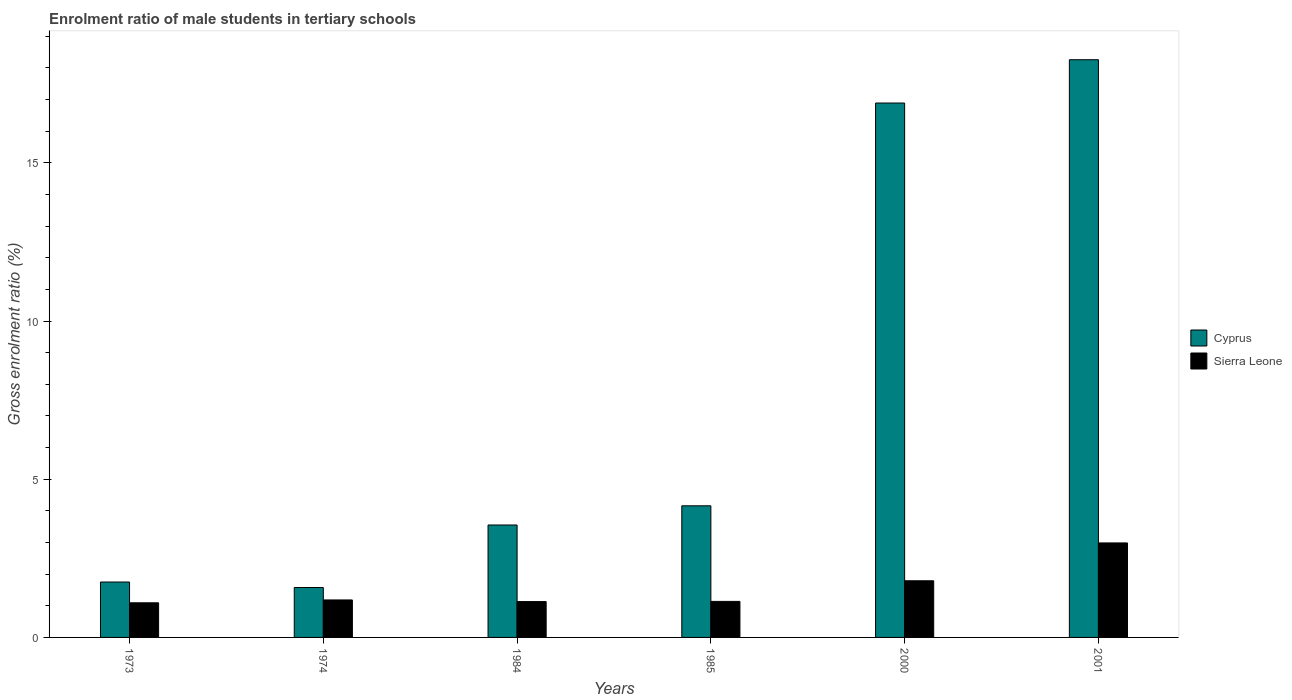How many different coloured bars are there?
Make the answer very short. 2. Are the number of bars per tick equal to the number of legend labels?
Your response must be concise. Yes. Are the number of bars on each tick of the X-axis equal?
Offer a very short reply. Yes. How many bars are there on the 6th tick from the left?
Offer a very short reply. 2. How many bars are there on the 6th tick from the right?
Your response must be concise. 2. What is the label of the 2nd group of bars from the left?
Provide a short and direct response. 1974. In how many cases, is the number of bars for a given year not equal to the number of legend labels?
Your response must be concise. 0. What is the enrolment ratio of male students in tertiary schools in Sierra Leone in 1984?
Your answer should be very brief. 1.13. Across all years, what is the maximum enrolment ratio of male students in tertiary schools in Cyprus?
Your answer should be compact. 18.26. Across all years, what is the minimum enrolment ratio of male students in tertiary schools in Sierra Leone?
Provide a short and direct response. 1.09. In which year was the enrolment ratio of male students in tertiary schools in Sierra Leone minimum?
Offer a very short reply. 1973. What is the total enrolment ratio of male students in tertiary schools in Sierra Leone in the graph?
Make the answer very short. 9.33. What is the difference between the enrolment ratio of male students in tertiary schools in Cyprus in 1973 and that in 1984?
Give a very brief answer. -1.8. What is the difference between the enrolment ratio of male students in tertiary schools in Sierra Leone in 2000 and the enrolment ratio of male students in tertiary schools in Cyprus in 1973?
Your answer should be compact. 0.04. What is the average enrolment ratio of male students in tertiary schools in Sierra Leone per year?
Offer a terse response. 1.55. In the year 2001, what is the difference between the enrolment ratio of male students in tertiary schools in Sierra Leone and enrolment ratio of male students in tertiary schools in Cyprus?
Make the answer very short. -15.27. In how many years, is the enrolment ratio of male students in tertiary schools in Sierra Leone greater than 15 %?
Your response must be concise. 0. What is the ratio of the enrolment ratio of male students in tertiary schools in Sierra Leone in 1973 to that in 1984?
Offer a very short reply. 0.97. Is the enrolment ratio of male students in tertiary schools in Cyprus in 1973 less than that in 1984?
Give a very brief answer. Yes. What is the difference between the highest and the second highest enrolment ratio of male students in tertiary schools in Sierra Leone?
Your answer should be compact. 1.2. What is the difference between the highest and the lowest enrolment ratio of male students in tertiary schools in Sierra Leone?
Offer a very short reply. 1.89. What does the 2nd bar from the left in 1985 represents?
Offer a terse response. Sierra Leone. What does the 2nd bar from the right in 1985 represents?
Your answer should be very brief. Cyprus. How many bars are there?
Offer a terse response. 12. Are all the bars in the graph horizontal?
Your answer should be very brief. No. How many years are there in the graph?
Provide a succinct answer. 6. Are the values on the major ticks of Y-axis written in scientific E-notation?
Give a very brief answer. No. How many legend labels are there?
Provide a succinct answer. 2. What is the title of the graph?
Provide a short and direct response. Enrolment ratio of male students in tertiary schools. What is the label or title of the X-axis?
Offer a terse response. Years. What is the Gross enrolment ratio (%) in Cyprus in 1973?
Your response must be concise. 1.75. What is the Gross enrolment ratio (%) of Sierra Leone in 1973?
Your answer should be very brief. 1.09. What is the Gross enrolment ratio (%) in Cyprus in 1974?
Provide a short and direct response. 1.58. What is the Gross enrolment ratio (%) in Sierra Leone in 1974?
Provide a succinct answer. 1.18. What is the Gross enrolment ratio (%) in Cyprus in 1984?
Make the answer very short. 3.55. What is the Gross enrolment ratio (%) in Sierra Leone in 1984?
Provide a short and direct response. 1.13. What is the Gross enrolment ratio (%) of Cyprus in 1985?
Provide a succinct answer. 4.16. What is the Gross enrolment ratio (%) in Sierra Leone in 1985?
Make the answer very short. 1.14. What is the Gross enrolment ratio (%) of Cyprus in 2000?
Offer a very short reply. 16.89. What is the Gross enrolment ratio (%) of Sierra Leone in 2000?
Keep it short and to the point. 1.79. What is the Gross enrolment ratio (%) of Cyprus in 2001?
Your answer should be very brief. 18.26. What is the Gross enrolment ratio (%) in Sierra Leone in 2001?
Your answer should be compact. 2.99. Across all years, what is the maximum Gross enrolment ratio (%) in Cyprus?
Your response must be concise. 18.26. Across all years, what is the maximum Gross enrolment ratio (%) in Sierra Leone?
Your response must be concise. 2.99. Across all years, what is the minimum Gross enrolment ratio (%) in Cyprus?
Keep it short and to the point. 1.58. Across all years, what is the minimum Gross enrolment ratio (%) of Sierra Leone?
Ensure brevity in your answer.  1.09. What is the total Gross enrolment ratio (%) in Cyprus in the graph?
Your response must be concise. 46.19. What is the total Gross enrolment ratio (%) in Sierra Leone in the graph?
Your response must be concise. 9.33. What is the difference between the Gross enrolment ratio (%) of Cyprus in 1973 and that in 1974?
Your response must be concise. 0.17. What is the difference between the Gross enrolment ratio (%) of Sierra Leone in 1973 and that in 1974?
Give a very brief answer. -0.09. What is the difference between the Gross enrolment ratio (%) in Cyprus in 1973 and that in 1984?
Offer a very short reply. -1.8. What is the difference between the Gross enrolment ratio (%) of Sierra Leone in 1973 and that in 1984?
Ensure brevity in your answer.  -0.04. What is the difference between the Gross enrolment ratio (%) of Cyprus in 1973 and that in 1985?
Provide a succinct answer. -2.41. What is the difference between the Gross enrolment ratio (%) of Sierra Leone in 1973 and that in 1985?
Offer a terse response. -0.04. What is the difference between the Gross enrolment ratio (%) in Cyprus in 1973 and that in 2000?
Offer a very short reply. -15.14. What is the difference between the Gross enrolment ratio (%) of Sierra Leone in 1973 and that in 2000?
Give a very brief answer. -0.7. What is the difference between the Gross enrolment ratio (%) of Cyprus in 1973 and that in 2001?
Provide a short and direct response. -16.51. What is the difference between the Gross enrolment ratio (%) of Sierra Leone in 1973 and that in 2001?
Offer a very short reply. -1.89. What is the difference between the Gross enrolment ratio (%) of Cyprus in 1974 and that in 1984?
Your answer should be very brief. -1.98. What is the difference between the Gross enrolment ratio (%) of Sierra Leone in 1974 and that in 1984?
Your answer should be compact. 0.05. What is the difference between the Gross enrolment ratio (%) of Cyprus in 1974 and that in 1985?
Give a very brief answer. -2.58. What is the difference between the Gross enrolment ratio (%) in Sierra Leone in 1974 and that in 1985?
Ensure brevity in your answer.  0.05. What is the difference between the Gross enrolment ratio (%) of Cyprus in 1974 and that in 2000?
Offer a terse response. -15.31. What is the difference between the Gross enrolment ratio (%) in Sierra Leone in 1974 and that in 2000?
Provide a short and direct response. -0.61. What is the difference between the Gross enrolment ratio (%) of Cyprus in 1974 and that in 2001?
Give a very brief answer. -16.68. What is the difference between the Gross enrolment ratio (%) in Sierra Leone in 1974 and that in 2001?
Make the answer very short. -1.8. What is the difference between the Gross enrolment ratio (%) in Cyprus in 1984 and that in 1985?
Make the answer very short. -0.61. What is the difference between the Gross enrolment ratio (%) of Sierra Leone in 1984 and that in 1985?
Provide a succinct answer. -0.01. What is the difference between the Gross enrolment ratio (%) in Cyprus in 1984 and that in 2000?
Your response must be concise. -13.34. What is the difference between the Gross enrolment ratio (%) in Sierra Leone in 1984 and that in 2000?
Your answer should be very brief. -0.66. What is the difference between the Gross enrolment ratio (%) in Cyprus in 1984 and that in 2001?
Give a very brief answer. -14.71. What is the difference between the Gross enrolment ratio (%) in Sierra Leone in 1984 and that in 2001?
Your answer should be very brief. -1.85. What is the difference between the Gross enrolment ratio (%) of Cyprus in 1985 and that in 2000?
Keep it short and to the point. -12.73. What is the difference between the Gross enrolment ratio (%) of Sierra Leone in 1985 and that in 2000?
Provide a short and direct response. -0.65. What is the difference between the Gross enrolment ratio (%) of Cyprus in 1985 and that in 2001?
Ensure brevity in your answer.  -14.1. What is the difference between the Gross enrolment ratio (%) of Sierra Leone in 1985 and that in 2001?
Provide a short and direct response. -1.85. What is the difference between the Gross enrolment ratio (%) in Cyprus in 2000 and that in 2001?
Provide a short and direct response. -1.37. What is the difference between the Gross enrolment ratio (%) in Sierra Leone in 2000 and that in 2001?
Provide a short and direct response. -1.2. What is the difference between the Gross enrolment ratio (%) of Cyprus in 1973 and the Gross enrolment ratio (%) of Sierra Leone in 1974?
Offer a very short reply. 0.57. What is the difference between the Gross enrolment ratio (%) of Cyprus in 1973 and the Gross enrolment ratio (%) of Sierra Leone in 1984?
Offer a terse response. 0.62. What is the difference between the Gross enrolment ratio (%) of Cyprus in 1973 and the Gross enrolment ratio (%) of Sierra Leone in 1985?
Your response must be concise. 0.61. What is the difference between the Gross enrolment ratio (%) of Cyprus in 1973 and the Gross enrolment ratio (%) of Sierra Leone in 2000?
Provide a succinct answer. -0.04. What is the difference between the Gross enrolment ratio (%) of Cyprus in 1973 and the Gross enrolment ratio (%) of Sierra Leone in 2001?
Your response must be concise. -1.24. What is the difference between the Gross enrolment ratio (%) in Cyprus in 1974 and the Gross enrolment ratio (%) in Sierra Leone in 1984?
Ensure brevity in your answer.  0.44. What is the difference between the Gross enrolment ratio (%) in Cyprus in 1974 and the Gross enrolment ratio (%) in Sierra Leone in 1985?
Ensure brevity in your answer.  0.44. What is the difference between the Gross enrolment ratio (%) in Cyprus in 1974 and the Gross enrolment ratio (%) in Sierra Leone in 2000?
Give a very brief answer. -0.21. What is the difference between the Gross enrolment ratio (%) in Cyprus in 1974 and the Gross enrolment ratio (%) in Sierra Leone in 2001?
Offer a very short reply. -1.41. What is the difference between the Gross enrolment ratio (%) of Cyprus in 1984 and the Gross enrolment ratio (%) of Sierra Leone in 1985?
Your response must be concise. 2.42. What is the difference between the Gross enrolment ratio (%) of Cyprus in 1984 and the Gross enrolment ratio (%) of Sierra Leone in 2000?
Give a very brief answer. 1.76. What is the difference between the Gross enrolment ratio (%) in Cyprus in 1984 and the Gross enrolment ratio (%) in Sierra Leone in 2001?
Your answer should be very brief. 0.57. What is the difference between the Gross enrolment ratio (%) of Cyprus in 1985 and the Gross enrolment ratio (%) of Sierra Leone in 2000?
Offer a terse response. 2.37. What is the difference between the Gross enrolment ratio (%) of Cyprus in 1985 and the Gross enrolment ratio (%) of Sierra Leone in 2001?
Make the answer very short. 1.17. What is the difference between the Gross enrolment ratio (%) of Cyprus in 2000 and the Gross enrolment ratio (%) of Sierra Leone in 2001?
Offer a terse response. 13.9. What is the average Gross enrolment ratio (%) of Cyprus per year?
Ensure brevity in your answer.  7.7. What is the average Gross enrolment ratio (%) of Sierra Leone per year?
Provide a short and direct response. 1.55. In the year 1973, what is the difference between the Gross enrolment ratio (%) in Cyprus and Gross enrolment ratio (%) in Sierra Leone?
Your answer should be very brief. 0.66. In the year 1974, what is the difference between the Gross enrolment ratio (%) in Cyprus and Gross enrolment ratio (%) in Sierra Leone?
Offer a very short reply. 0.39. In the year 1984, what is the difference between the Gross enrolment ratio (%) in Cyprus and Gross enrolment ratio (%) in Sierra Leone?
Ensure brevity in your answer.  2.42. In the year 1985, what is the difference between the Gross enrolment ratio (%) in Cyprus and Gross enrolment ratio (%) in Sierra Leone?
Your answer should be very brief. 3.02. In the year 2000, what is the difference between the Gross enrolment ratio (%) of Cyprus and Gross enrolment ratio (%) of Sierra Leone?
Offer a terse response. 15.1. In the year 2001, what is the difference between the Gross enrolment ratio (%) in Cyprus and Gross enrolment ratio (%) in Sierra Leone?
Ensure brevity in your answer.  15.27. What is the ratio of the Gross enrolment ratio (%) of Cyprus in 1973 to that in 1974?
Ensure brevity in your answer.  1.11. What is the ratio of the Gross enrolment ratio (%) of Sierra Leone in 1973 to that in 1974?
Provide a succinct answer. 0.92. What is the ratio of the Gross enrolment ratio (%) in Cyprus in 1973 to that in 1984?
Offer a terse response. 0.49. What is the ratio of the Gross enrolment ratio (%) in Sierra Leone in 1973 to that in 1984?
Offer a terse response. 0.97. What is the ratio of the Gross enrolment ratio (%) in Cyprus in 1973 to that in 1985?
Keep it short and to the point. 0.42. What is the ratio of the Gross enrolment ratio (%) in Sierra Leone in 1973 to that in 1985?
Your answer should be compact. 0.96. What is the ratio of the Gross enrolment ratio (%) in Cyprus in 1973 to that in 2000?
Provide a succinct answer. 0.1. What is the ratio of the Gross enrolment ratio (%) of Sierra Leone in 1973 to that in 2000?
Provide a succinct answer. 0.61. What is the ratio of the Gross enrolment ratio (%) in Cyprus in 1973 to that in 2001?
Provide a succinct answer. 0.1. What is the ratio of the Gross enrolment ratio (%) of Sierra Leone in 1973 to that in 2001?
Offer a terse response. 0.37. What is the ratio of the Gross enrolment ratio (%) in Cyprus in 1974 to that in 1984?
Your answer should be compact. 0.44. What is the ratio of the Gross enrolment ratio (%) of Sierra Leone in 1974 to that in 1984?
Your answer should be compact. 1.05. What is the ratio of the Gross enrolment ratio (%) in Cyprus in 1974 to that in 1985?
Keep it short and to the point. 0.38. What is the ratio of the Gross enrolment ratio (%) in Sierra Leone in 1974 to that in 1985?
Offer a very short reply. 1.04. What is the ratio of the Gross enrolment ratio (%) of Cyprus in 1974 to that in 2000?
Offer a very short reply. 0.09. What is the ratio of the Gross enrolment ratio (%) in Sierra Leone in 1974 to that in 2000?
Give a very brief answer. 0.66. What is the ratio of the Gross enrolment ratio (%) of Cyprus in 1974 to that in 2001?
Offer a terse response. 0.09. What is the ratio of the Gross enrolment ratio (%) in Sierra Leone in 1974 to that in 2001?
Ensure brevity in your answer.  0.4. What is the ratio of the Gross enrolment ratio (%) in Cyprus in 1984 to that in 1985?
Offer a terse response. 0.85. What is the ratio of the Gross enrolment ratio (%) of Sierra Leone in 1984 to that in 1985?
Provide a short and direct response. 1. What is the ratio of the Gross enrolment ratio (%) in Cyprus in 1984 to that in 2000?
Make the answer very short. 0.21. What is the ratio of the Gross enrolment ratio (%) in Sierra Leone in 1984 to that in 2000?
Give a very brief answer. 0.63. What is the ratio of the Gross enrolment ratio (%) in Cyprus in 1984 to that in 2001?
Offer a very short reply. 0.19. What is the ratio of the Gross enrolment ratio (%) of Sierra Leone in 1984 to that in 2001?
Your response must be concise. 0.38. What is the ratio of the Gross enrolment ratio (%) of Cyprus in 1985 to that in 2000?
Provide a short and direct response. 0.25. What is the ratio of the Gross enrolment ratio (%) in Sierra Leone in 1985 to that in 2000?
Give a very brief answer. 0.64. What is the ratio of the Gross enrolment ratio (%) of Cyprus in 1985 to that in 2001?
Your answer should be very brief. 0.23. What is the ratio of the Gross enrolment ratio (%) of Sierra Leone in 1985 to that in 2001?
Ensure brevity in your answer.  0.38. What is the ratio of the Gross enrolment ratio (%) in Cyprus in 2000 to that in 2001?
Offer a terse response. 0.93. What is the ratio of the Gross enrolment ratio (%) of Sierra Leone in 2000 to that in 2001?
Make the answer very short. 0.6. What is the difference between the highest and the second highest Gross enrolment ratio (%) in Cyprus?
Offer a very short reply. 1.37. What is the difference between the highest and the second highest Gross enrolment ratio (%) in Sierra Leone?
Your answer should be very brief. 1.2. What is the difference between the highest and the lowest Gross enrolment ratio (%) of Cyprus?
Offer a terse response. 16.68. What is the difference between the highest and the lowest Gross enrolment ratio (%) in Sierra Leone?
Ensure brevity in your answer.  1.89. 